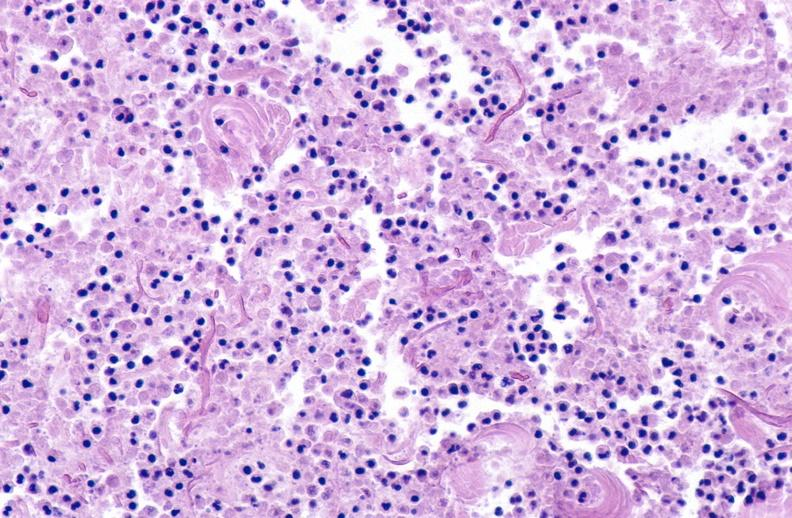does good example of muscle atrophy show panniculitis and fascitis?
Answer the question using a single word or phrase. No 